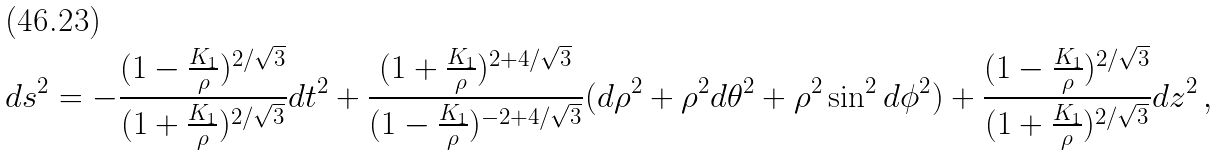<formula> <loc_0><loc_0><loc_500><loc_500>d s ^ { 2 } = - \frac { ( 1 - \frac { K _ { 1 } } { \rho } ) ^ { 2 / \sqrt { 3 } } } { ( 1 + \frac { K _ { 1 } } { \rho } ) ^ { 2 / \sqrt { 3 } } } d t ^ { 2 } + \frac { ( 1 + \frac { K _ { 1 } } { \rho } ) ^ { 2 + 4 / \sqrt { 3 } } } { ( 1 - \frac { K _ { 1 } } { \rho } ) ^ { - 2 + 4 / \sqrt { 3 } } } ( d \rho ^ { 2 } + \rho ^ { 2 } d \theta ^ { 2 } + \rho ^ { 2 } \sin ^ { 2 } d \phi ^ { 2 } ) + \frac { ( 1 - \frac { K _ { 1 } } { \rho } ) ^ { 2 / \sqrt { 3 } } } { ( 1 + \frac { K _ { 1 } } { \rho } ) ^ { 2 / \sqrt { 3 } } } d z ^ { 2 } \, ,</formula> 